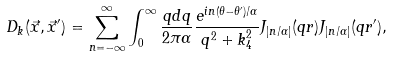Convert formula to latex. <formula><loc_0><loc_0><loc_500><loc_500>D _ { k } ( \vec { x } , \vec { x } ^ { \prime } ) = \sum _ { n = - \infty } ^ { \infty } \int _ { 0 } ^ { \infty } \frac { q d q } { 2 \pi \alpha } \frac { e ^ { i n ( \theta - \theta ^ { \prime } ) / \alpha } } { q ^ { 2 } + k _ { 4 } ^ { 2 } } J _ { | n / \alpha | } ( q r ) J _ { | n / \alpha | } ( q r ^ { \prime } ) ,</formula> 